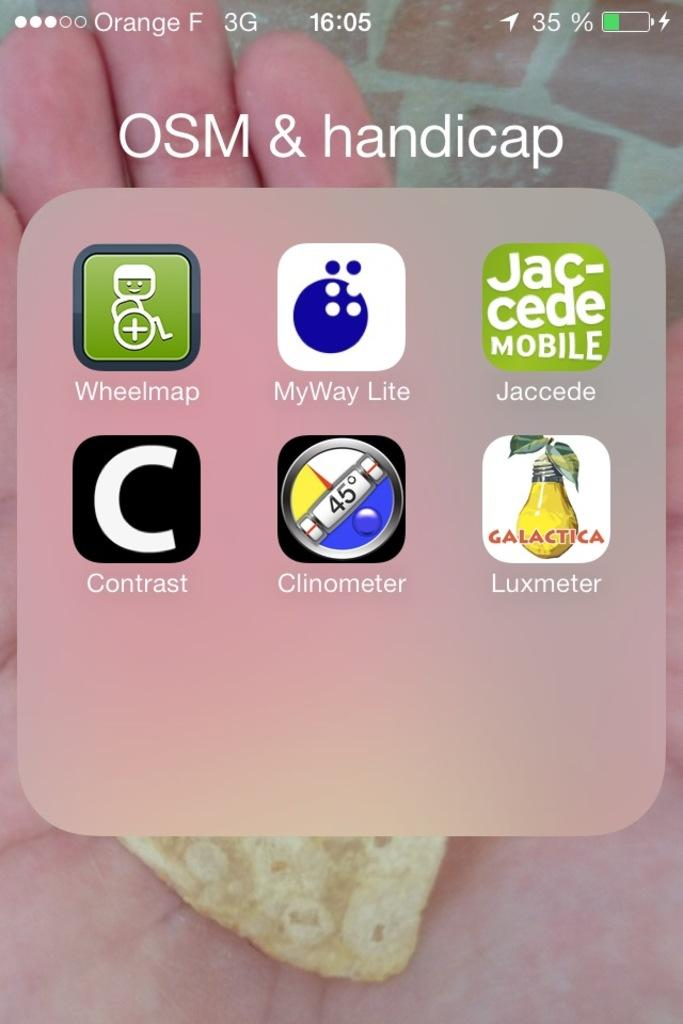Provide a one-sentence caption for the provided image. A folder in a smart phone labeled OSM & handicap. 